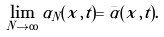<formula> <loc_0><loc_0><loc_500><loc_500>\lim _ { N \to \infty } \alpha _ { N } ( x , t ) = \bar { \alpha } ( x , t ) .</formula> 